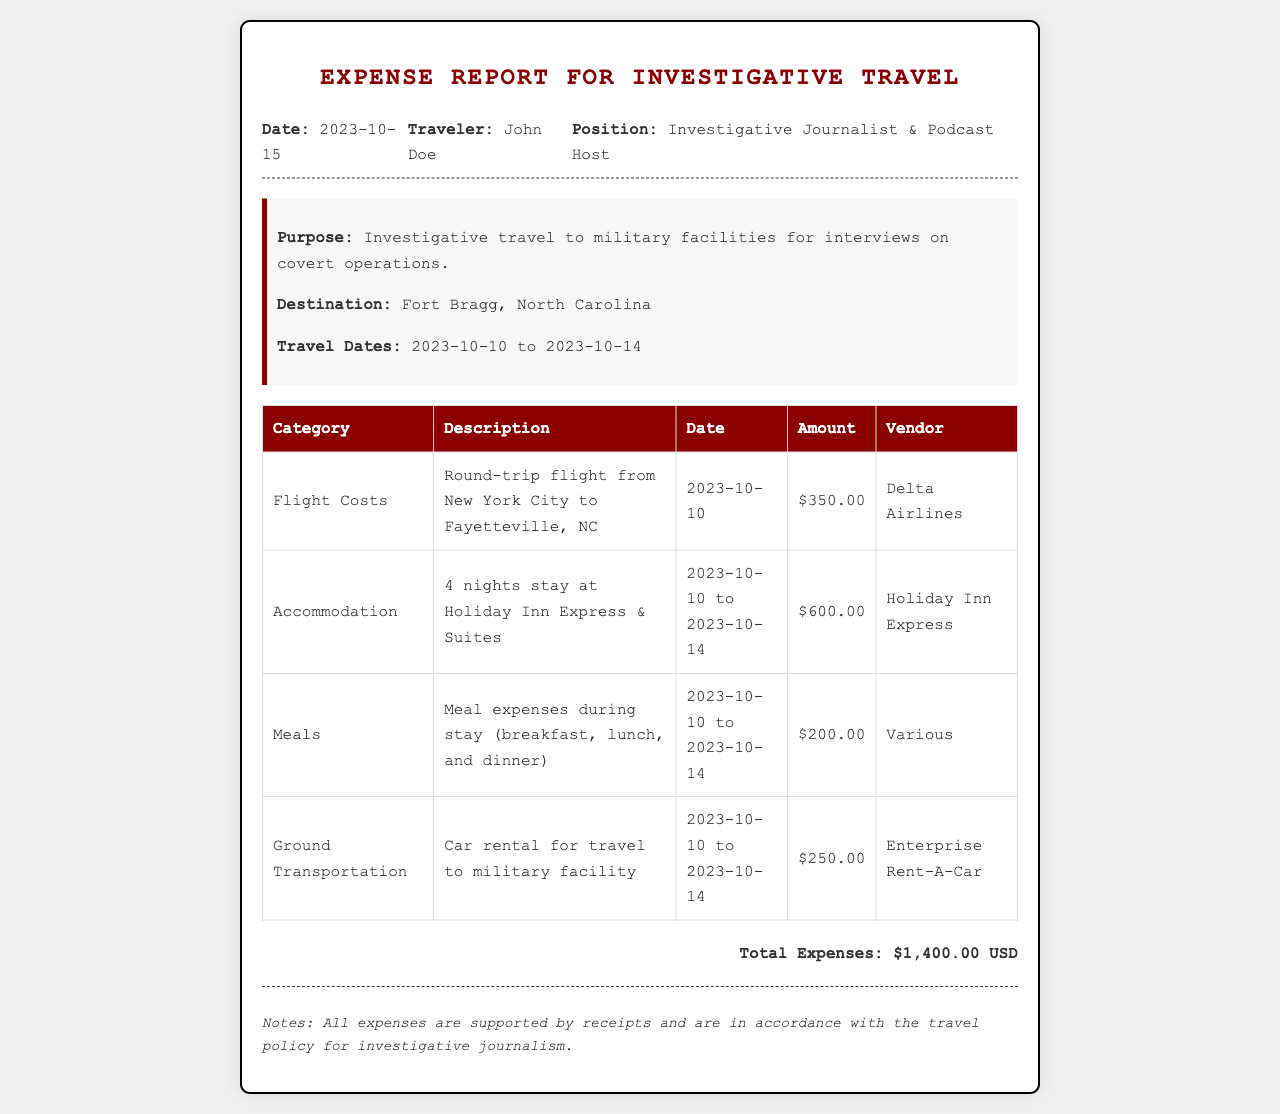What is the total expense? The total expense is a summation of all expenses listed in the document, which amounts to $350.00 + $600.00 + $200.00 + $250.00 = $1,400.00 USD.
Answer: $1,400.00 USD Who is the traveler? The traveler is the individual listed at the top of the document under the section “Traveler.”
Answer: John Doe What was the accommodation cost? The accommodation cost is specified for the stay duration and is clearly listed in the document.
Answer: $600.00 What was the duration of the trip? The duration of the trip is specified in the travel dates section, indicating the beginning and ending dates.
Answer: 2023-10-10 to 2023-10-14 What type of car rental was used? The type of car rental is indicated under the ground transportation section, reflecting the vendor used for that service.
Answer: Enterprise Rent-A-Car How much was spent on meals? The amount spent on meals is clearly stated under the meals category of expenses.
Answer: $200.00 What was the purpose of the trip? The purpose of the trip is briefly outlined in the trip details section of the document.
Answer: Investigative travel to military facilities for interviews on covert operations On what date did the flight occur? The date of the flight is detailed under the flight costs category of expenses, reflecting the travel day.
Answer: 2023-10-10 